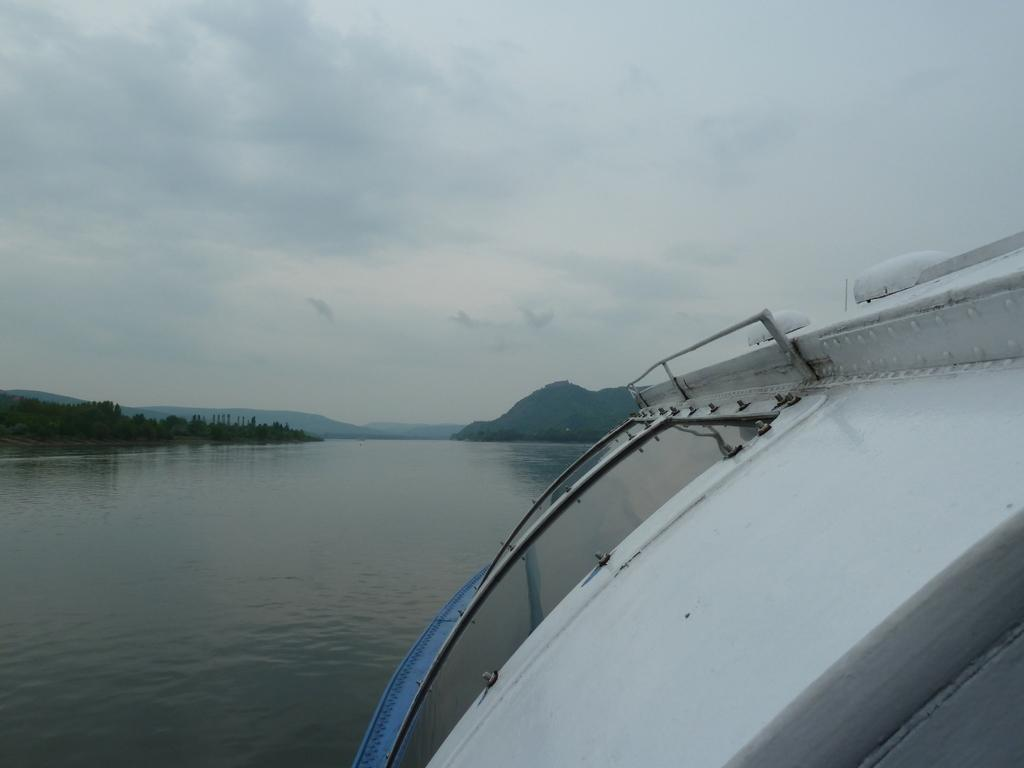What type of boat is in the water in the image? There is a white color boat in the water in the image. What can be seen in the background of the image? Mountains with trees are visible in the background of the image. What color is the sky in the image? The sky is blue in the image. Are there any clouds visible in the sky? Yes, clouds are present in the sky in the image. Where is the nest of the fairies located in the image? There is no nest or fairies present in the image. 